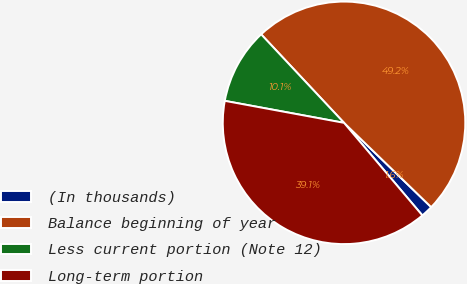<chart> <loc_0><loc_0><loc_500><loc_500><pie_chart><fcel>(In thousands)<fcel>Balance beginning of year<fcel>Less current portion (Note 12)<fcel>Long-term portion<nl><fcel>1.59%<fcel>49.21%<fcel>10.12%<fcel>39.08%<nl></chart> 